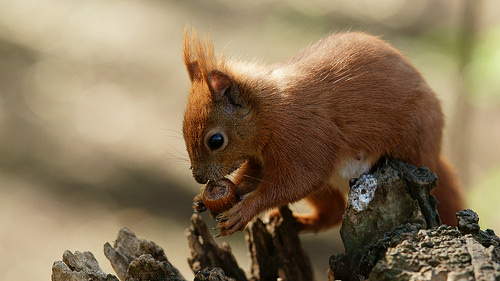<image>
Is there a squirrel next to the log? No. The squirrel is not positioned next to the log. They are located in different areas of the scene. 